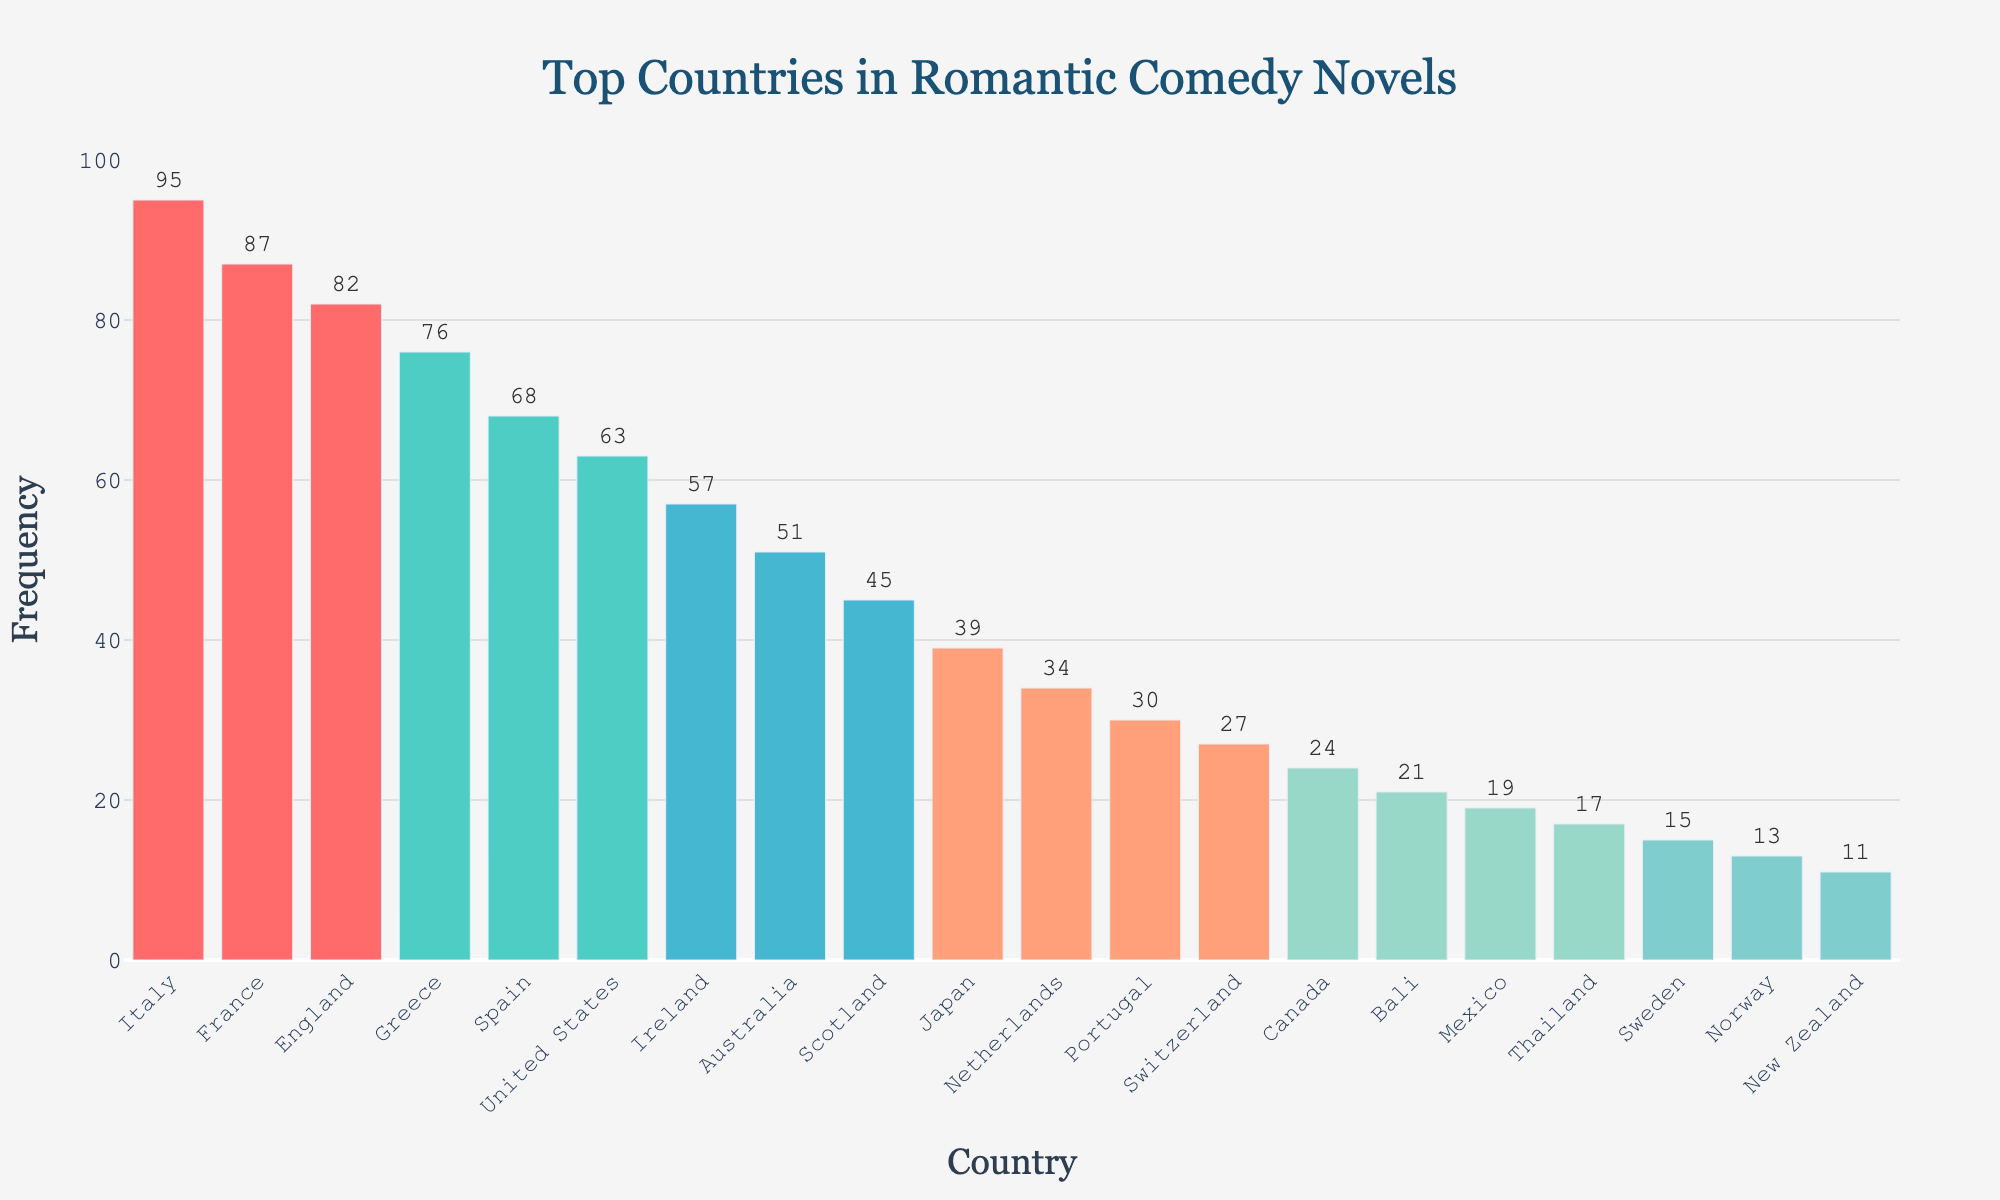Which country is visited most frequently in romantic comedy novels? Italy has the highest frequency bar in the chart, indicating it is the most frequently visited country in romantic comedy novels.
Answer: Italy How many more times is France visited compared to Japan in romantic comedy novels? France is visited 87 times and Japan 39 times. Subtract Japan's frequency from France's (87 - 39 = 48) to find the difference.
Answer: 48 Which two countries have the closest frequency of visits in romantic comedy novels? Comparing the heights of the bars, Ireland (57) and Australia (51) have the closest frequencies. Subtract their frequencies (57 - 51 = 6) to find the difference is smallest.
Answer: Ireland and Australia What is the combined frequency of visits for the top three most frequently visited countries? The top three countries are Italy (95), France (87), and England (82). Sum their frequencies (95 + 87 + 82 = 264).
Answer: 264 Which country ranks fifth in frequency of visits? From the sorted bars, Spain is the fifth highest with a frequency of 68.
Answer: Spain What are the colors of the bars representing the top and bottom countries? The top country Italy's bar is red, and the bottom country New Zealand’s bar is a shade of blue-green.
Answer: red, blue-green How does the frequency of visits in Spain compare to that of the United States? Spain’s bar (68) is slightly higher than the United States’ bar (63), indicating Spain is visited 5 more times in romantic comedy novels.
Answer: Spain is visited 5 more times What is the average frequency of the top four countries? The top four countries are Italy (95), France (87), England (82), and Greece (76). Their total frequency is (95 + 87 + 82 + 76 = 340). Divide by 4 to get the average (340 / 4 = 85).
Answer: 85 Is Australia visited more or less frequently than Scotland? Australia's bar (51) is higher than Scotland's bar (45), indicating it is visited more frequently.
Answer: Australia is visited more frequently What percentage of the total visits do the top three countries account for? Sum the visits of the top three countries: Italy (95), France (87), and England (82), total (95 + 87 + 82 = 264). Sum the total visits of all countries (95 + 87 + 82 + 76 + 68 + 63 + 57 + 51 + 45 + 39 + 34 + 30 + 27 + 24 + 21 + 19 + 17 + 15 + 13 + 11 = 974). Calculate percentage (264 / 974 * 100 ≈ 27.1%).
Answer: 27.1% 